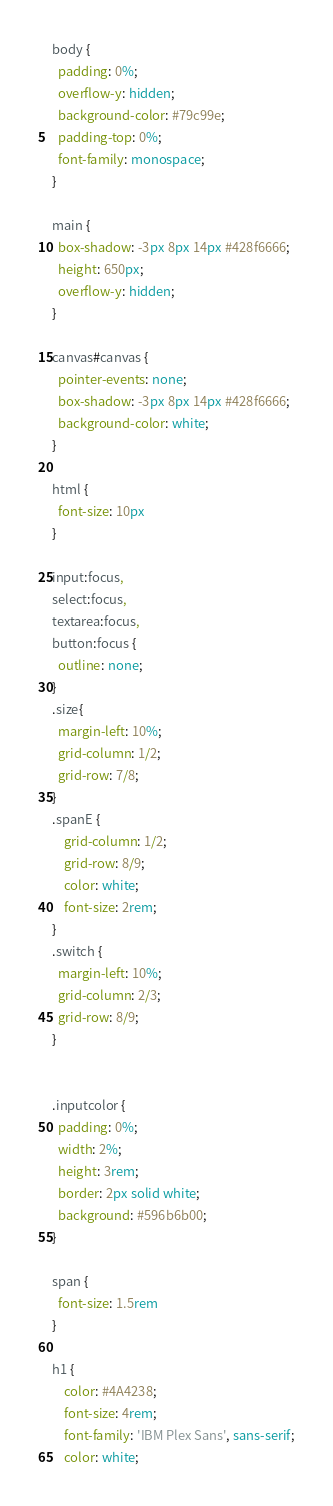<code> <loc_0><loc_0><loc_500><loc_500><_CSS_>body {
  padding: 0%;
  overflow-y: hidden;
  background-color: #79c99e;
  padding-top: 0%;
  font-family: monospace;
}

main {
  box-shadow: -3px 8px 14px #428f6666;
  height: 650px;
  overflow-y: hidden;
}

canvas#canvas {
  pointer-events: none;
  box-shadow: -3px 8px 14px #428f6666;
  background-color: white;
}

html {
  font-size: 10px
}

input:focus,
select:focus,
textarea:focus,
button:focus {
  outline: none;
}
.size{
  margin-left: 10%;
  grid-column: 1/2;
  grid-row: 7/8;
}
.spanE {
    grid-column: 1/2;
    grid-row: 8/9;
    color: white;
    font-size: 2rem;
}
.switch {
  margin-left: 10%;
  grid-column: 2/3;
  grid-row: 8/9;
}


.inputcolor {
  padding: 0%;
  width: 2%;
  height: 3rem;
  border: 2px solid white;
  background: #596b6b00;
}

span {
  font-size: 1.5rem
}

h1 {
    color: #4A4238;
    font-size: 4rem;
    font-family: 'IBM Plex Sans', sans-serif;
    color: white;</code> 